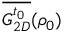Convert formula to latex. <formula><loc_0><loc_0><loc_500><loc_500>\overline { { G _ { 2 D } ^ { t _ { 0 } } } } ( \rho _ { 0 } )</formula> 